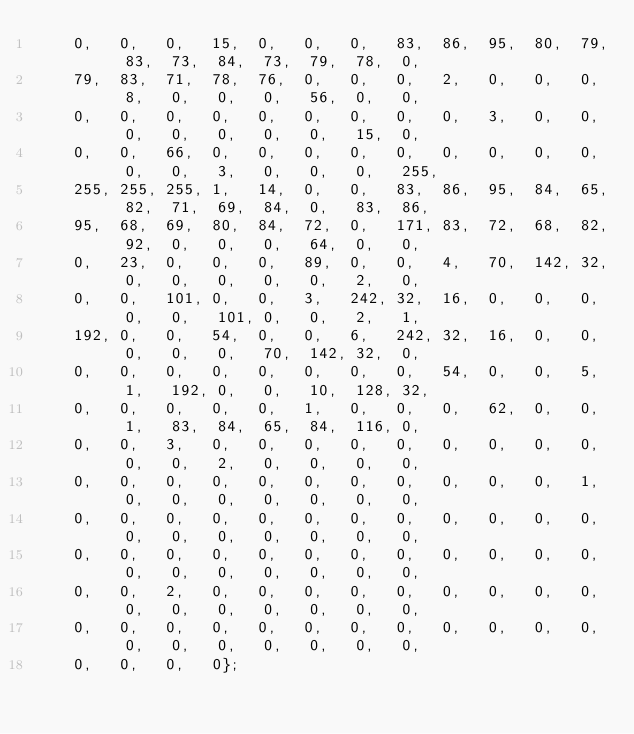<code> <loc_0><loc_0><loc_500><loc_500><_C_>    0,   0,   0,   15,  0,   0,   0,   83,  86,  95,  80,  79,  83,  73,  84,  73,  79,  78,  0,
    79,  83,  71,  78,  76,  0,   0,   0,   2,   0,   0,   0,   8,   0,   0,   0,   56,  0,   0,
    0,   0,   0,   0,   0,   0,   0,   0,   0,   3,   0,   0,   0,   0,   0,   0,   0,   15,  0,
    0,   0,   66,  0,   0,   0,   0,   0,   0,   0,   0,   0,   0,   0,   3,   0,   0,   0,   255,
    255, 255, 255, 1,   14,  0,   0,   83,  86,  95,  84,  65,  82,  71,  69,  84,  0,   83,  86,
    95,  68,  69,  80,  84,  72,  0,   171, 83,  72,  68,  82,  92,  0,   0,   0,   64,  0,   0,
    0,   23,  0,   0,   0,   89,  0,   0,   4,   70,  142, 32,  0,   0,   0,   0,   0,   2,   0,
    0,   0,   101, 0,   0,   3,   242, 32,  16,  0,   0,   0,   0,   0,   101, 0,   0,   2,   1,
    192, 0,   0,   54,  0,   0,   6,   242, 32,  16,  0,   0,   0,   0,   0,   70,  142, 32,  0,
    0,   0,   0,   0,   0,   0,   0,   0,   54,  0,   0,   5,   1,   192, 0,   0,   10,  128, 32,
    0,   0,   0,   0,   0,   1,   0,   0,   0,   62,  0,   0,   1,   83,  84,  65,  84,  116, 0,
    0,   0,   3,   0,   0,   0,   0,   0,   0,   0,   0,   0,   0,   0,   2,   0,   0,   0,   0,
    0,   0,   0,   0,   0,   0,   0,   0,   0,   0,   0,   1,   0,   0,   0,   0,   0,   0,   0,
    0,   0,   0,   0,   0,   0,   0,   0,   0,   0,   0,   0,   0,   0,   0,   0,   0,   0,   0,
    0,   0,   0,   0,   0,   0,   0,   0,   0,   0,   0,   0,   0,   0,   0,   0,   0,   0,   0,
    0,   0,   2,   0,   0,   0,   0,   0,   0,   0,   0,   0,   0,   0,   0,   0,   0,   0,   0,
    0,   0,   0,   0,   0,   0,   0,   0,   0,   0,   0,   0,   0,   0,   0,   0,   0,   0,   0,
    0,   0,   0,   0};
</code> 